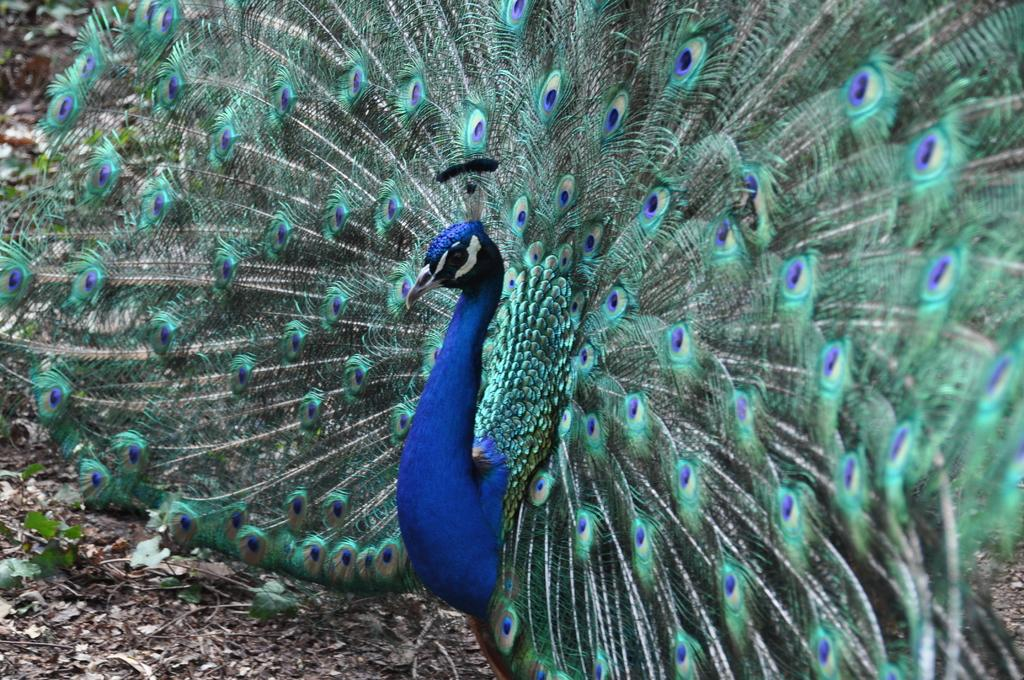What is the main subject in the center of the image? There is a peacock in the center of the image. What type of terrain is visible at the bottom of the image? There is dry grass at the bottom of the image. What other living organisms can be seen in the image? There are plants in the image. What type of shirt is the sister wearing during the discussion in the image? There is no shirt, sister, or discussion present in the image; it features a peacock and plants in a grassy area. 